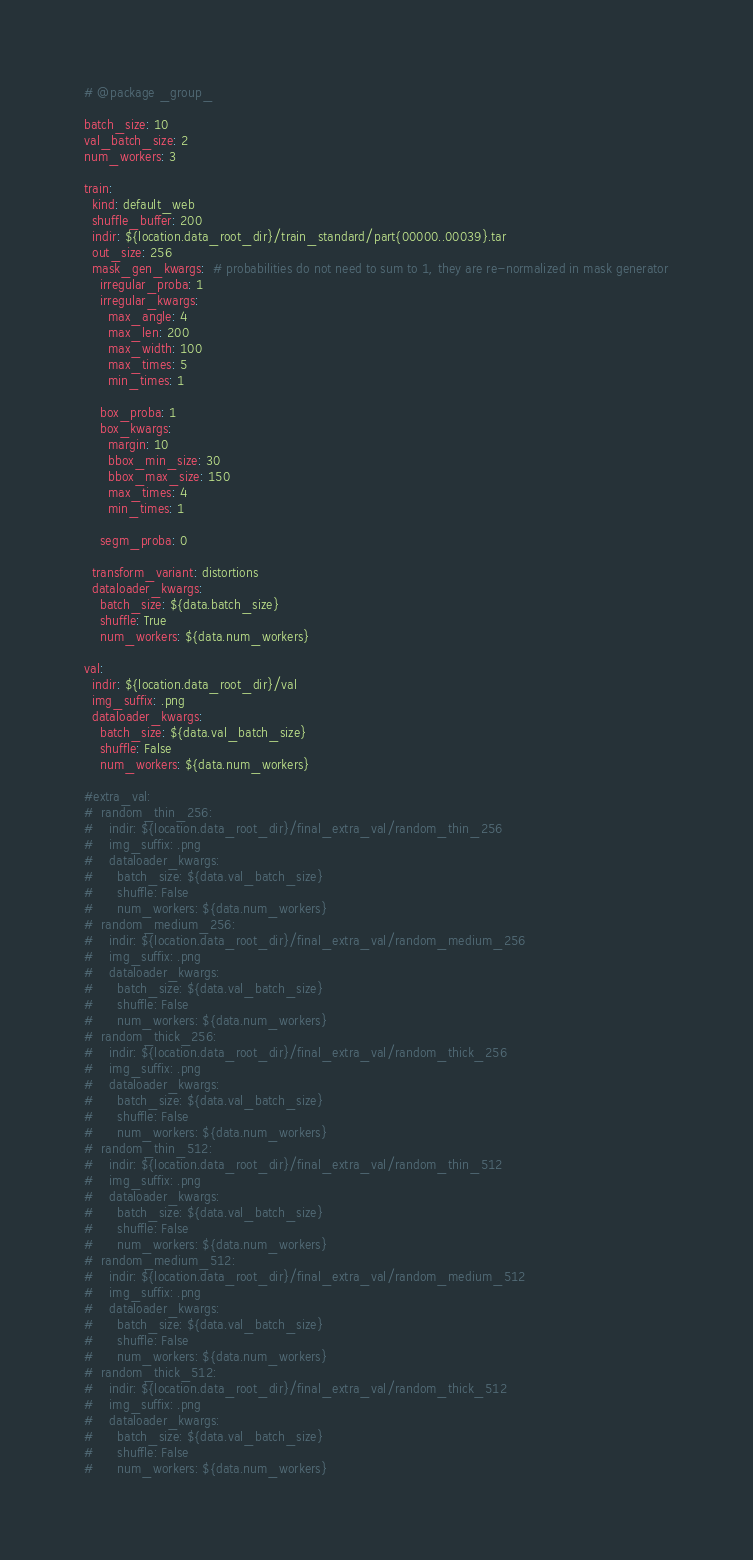<code> <loc_0><loc_0><loc_500><loc_500><_YAML_># @package _group_

batch_size: 10
val_batch_size: 2
num_workers: 3

train:
  kind: default_web
  shuffle_buffer: 200
  indir: ${location.data_root_dir}/train_standard/part{00000..00039}.tar
  out_size: 256
  mask_gen_kwargs:  # probabilities do not need to sum to 1, they are re-normalized in mask generator
    irregular_proba: 1
    irregular_kwargs:
      max_angle: 4
      max_len: 200
      max_width: 100
      max_times: 5
      min_times: 1

    box_proba: 1
    box_kwargs:
      margin: 10
      bbox_min_size: 30
      bbox_max_size: 150
      max_times: 4
      min_times: 1

    segm_proba: 0

  transform_variant: distortions
  dataloader_kwargs:
    batch_size: ${data.batch_size}
    shuffle: True
    num_workers: ${data.num_workers}

val:
  indir: ${location.data_root_dir}/val
  img_suffix: .png
  dataloader_kwargs:
    batch_size: ${data.val_batch_size}
    shuffle: False
    num_workers: ${data.num_workers}

#extra_val:
#  random_thin_256:
#    indir: ${location.data_root_dir}/final_extra_val/random_thin_256
#    img_suffix: .png
#    dataloader_kwargs:
#      batch_size: ${data.val_batch_size}
#      shuffle: False
#      num_workers: ${data.num_workers}
#  random_medium_256:
#    indir: ${location.data_root_dir}/final_extra_val/random_medium_256
#    img_suffix: .png
#    dataloader_kwargs:
#      batch_size: ${data.val_batch_size}
#      shuffle: False
#      num_workers: ${data.num_workers}
#  random_thick_256:
#    indir: ${location.data_root_dir}/final_extra_val/random_thick_256
#    img_suffix: .png
#    dataloader_kwargs:
#      batch_size: ${data.val_batch_size}
#      shuffle: False
#      num_workers: ${data.num_workers}
#  random_thin_512:
#    indir: ${location.data_root_dir}/final_extra_val/random_thin_512
#    img_suffix: .png
#    dataloader_kwargs:
#      batch_size: ${data.val_batch_size}
#      shuffle: False
#      num_workers: ${data.num_workers}
#  random_medium_512:
#    indir: ${location.data_root_dir}/final_extra_val/random_medium_512
#    img_suffix: .png
#    dataloader_kwargs:
#      batch_size: ${data.val_batch_size}
#      shuffle: False
#      num_workers: ${data.num_workers}
#  random_thick_512:
#    indir: ${location.data_root_dir}/final_extra_val/random_thick_512
#    img_suffix: .png
#    dataloader_kwargs:
#      batch_size: ${data.val_batch_size}
#      shuffle: False
#      num_workers: ${data.num_workers}</code> 